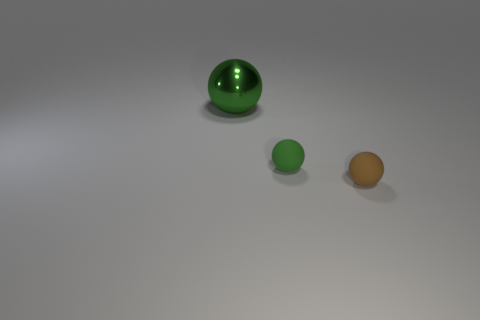Is there any other thing that is the same size as the green metal sphere?
Give a very brief answer. No. Is there anything else that is the same color as the large metal sphere?
Provide a succinct answer. Yes. There is a matte sphere that is behind the brown matte sphere; is it the same color as the large shiny ball?
Your response must be concise. Yes. How many green spheres are both on the left side of the small green object and in front of the metal ball?
Offer a very short reply. 0. The shiny object is what color?
Keep it short and to the point. Green. Are there any large green things made of the same material as the big sphere?
Your answer should be compact. No. Is there a rubber thing behind the tiny brown matte object that is in front of the green thing in front of the green shiny sphere?
Your answer should be very brief. Yes. There is a green matte ball; are there any small objects on the left side of it?
Offer a very short reply. No. Are there any large things of the same color as the large metallic sphere?
Your answer should be very brief. No. What number of big things are brown metallic things or brown matte things?
Your answer should be very brief. 0. 